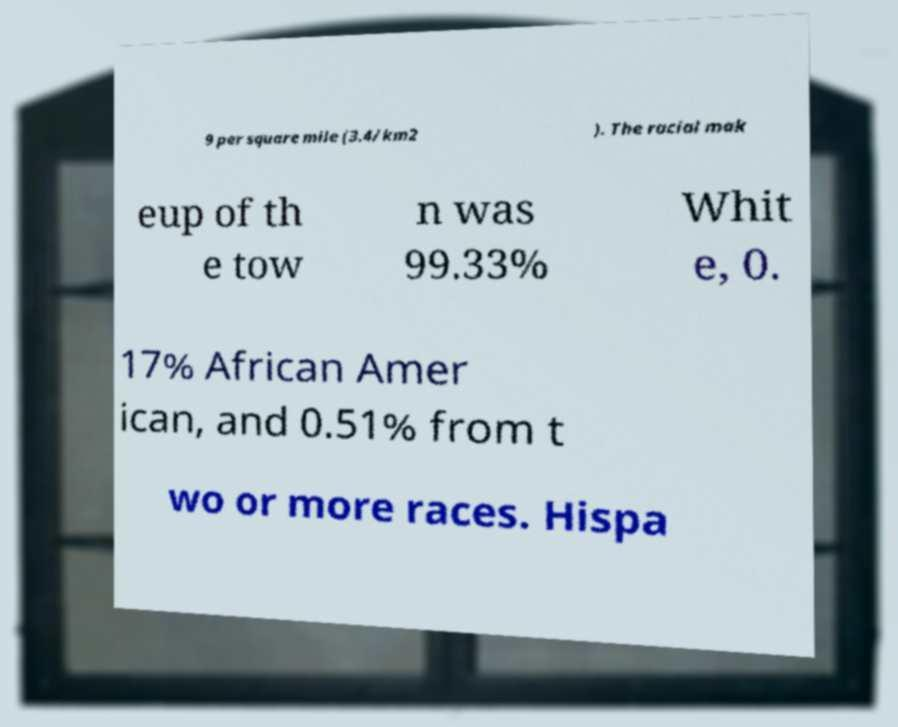Can you read and provide the text displayed in the image?This photo seems to have some interesting text. Can you extract and type it out for me? 9 per square mile (3.4/km2 ). The racial mak eup of th e tow n was 99.33% Whit e, 0. 17% African Amer ican, and 0.51% from t wo or more races. Hispa 